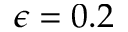Convert formula to latex. <formula><loc_0><loc_0><loc_500><loc_500>\epsilon = 0 . 2</formula> 